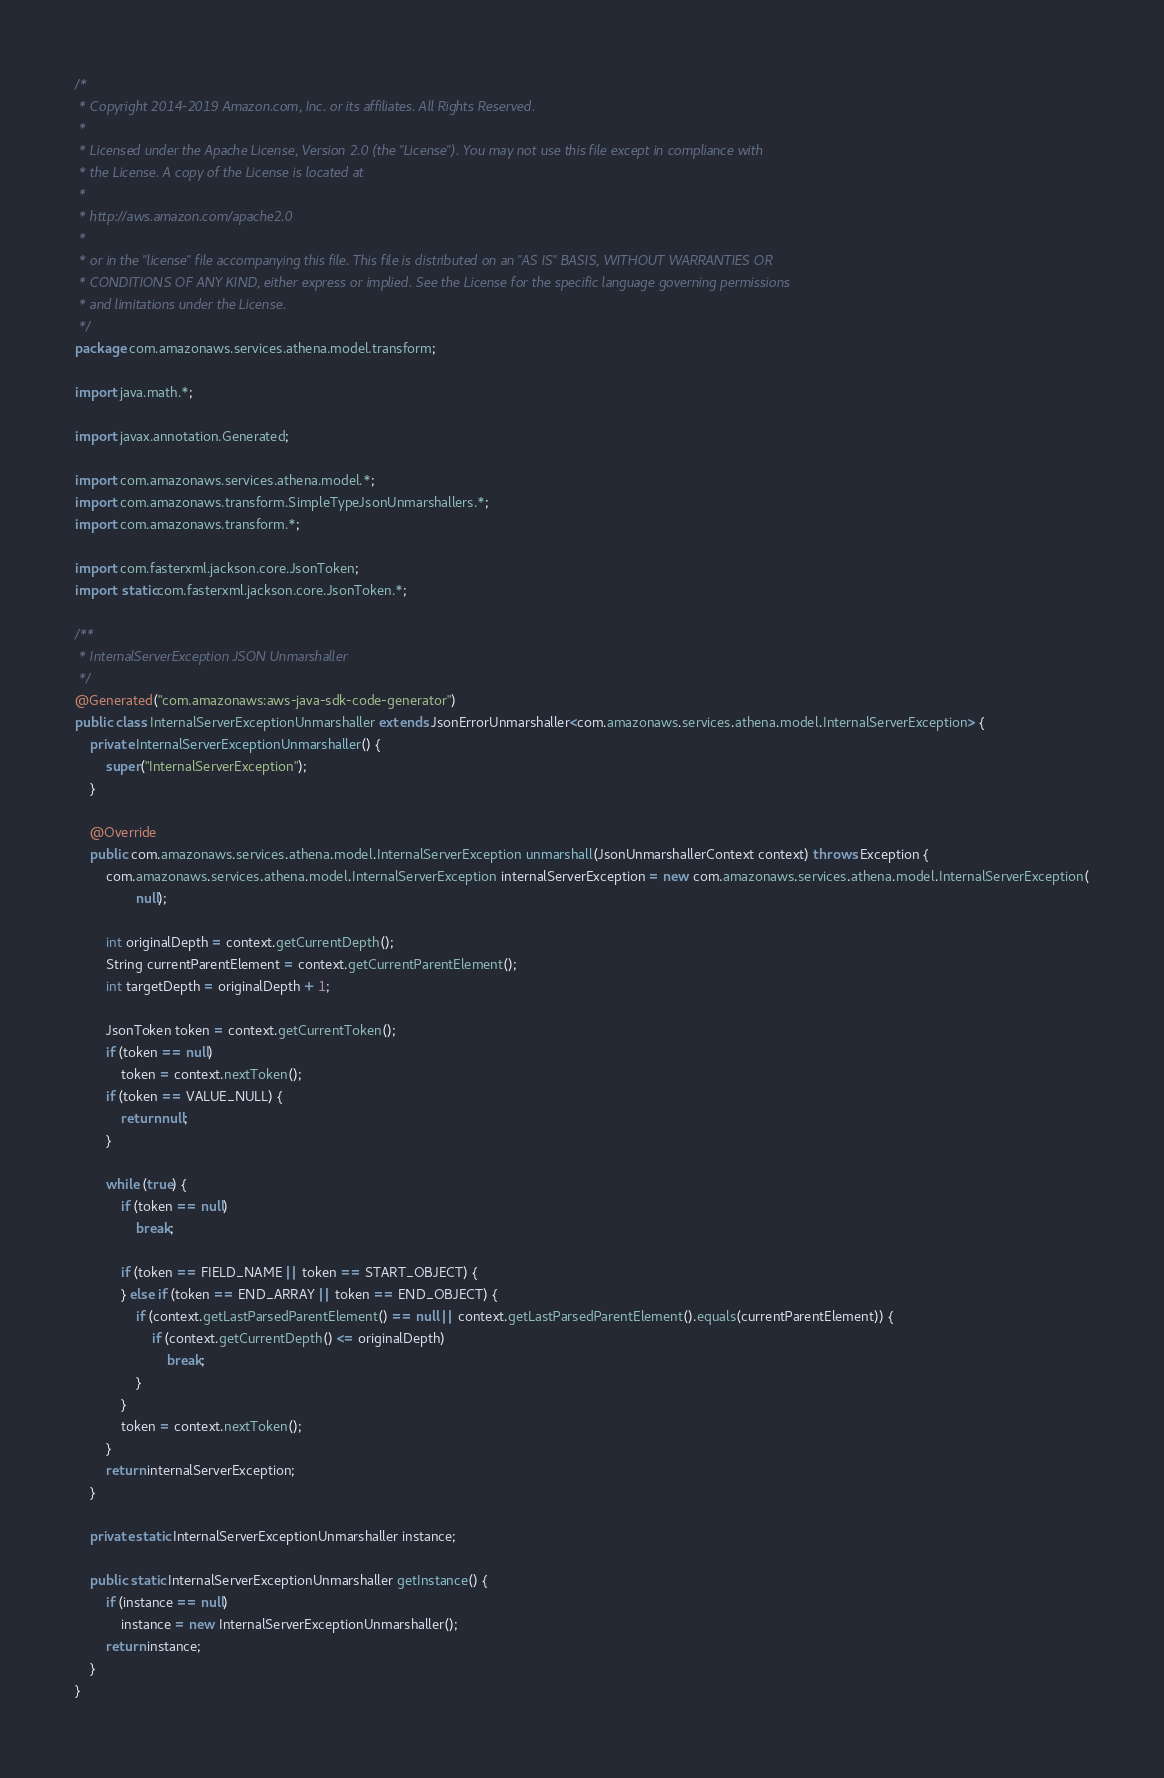Convert code to text. <code><loc_0><loc_0><loc_500><loc_500><_Java_>/*
 * Copyright 2014-2019 Amazon.com, Inc. or its affiliates. All Rights Reserved.
 * 
 * Licensed under the Apache License, Version 2.0 (the "License"). You may not use this file except in compliance with
 * the License. A copy of the License is located at
 * 
 * http://aws.amazon.com/apache2.0
 * 
 * or in the "license" file accompanying this file. This file is distributed on an "AS IS" BASIS, WITHOUT WARRANTIES OR
 * CONDITIONS OF ANY KIND, either express or implied. See the License for the specific language governing permissions
 * and limitations under the License.
 */
package com.amazonaws.services.athena.model.transform;

import java.math.*;

import javax.annotation.Generated;

import com.amazonaws.services.athena.model.*;
import com.amazonaws.transform.SimpleTypeJsonUnmarshallers.*;
import com.amazonaws.transform.*;

import com.fasterxml.jackson.core.JsonToken;
import static com.fasterxml.jackson.core.JsonToken.*;

/**
 * InternalServerException JSON Unmarshaller
 */
@Generated("com.amazonaws:aws-java-sdk-code-generator")
public class InternalServerExceptionUnmarshaller extends JsonErrorUnmarshaller<com.amazonaws.services.athena.model.InternalServerException> {
    private InternalServerExceptionUnmarshaller() {
        super("InternalServerException");
    }

    @Override
    public com.amazonaws.services.athena.model.InternalServerException unmarshall(JsonUnmarshallerContext context) throws Exception {
        com.amazonaws.services.athena.model.InternalServerException internalServerException = new com.amazonaws.services.athena.model.InternalServerException(
                null);

        int originalDepth = context.getCurrentDepth();
        String currentParentElement = context.getCurrentParentElement();
        int targetDepth = originalDepth + 1;

        JsonToken token = context.getCurrentToken();
        if (token == null)
            token = context.nextToken();
        if (token == VALUE_NULL) {
            return null;
        }

        while (true) {
            if (token == null)
                break;

            if (token == FIELD_NAME || token == START_OBJECT) {
            } else if (token == END_ARRAY || token == END_OBJECT) {
                if (context.getLastParsedParentElement() == null || context.getLastParsedParentElement().equals(currentParentElement)) {
                    if (context.getCurrentDepth() <= originalDepth)
                        break;
                }
            }
            token = context.nextToken();
        }
        return internalServerException;
    }

    private static InternalServerExceptionUnmarshaller instance;

    public static InternalServerExceptionUnmarshaller getInstance() {
        if (instance == null)
            instance = new InternalServerExceptionUnmarshaller();
        return instance;
    }
}
</code> 